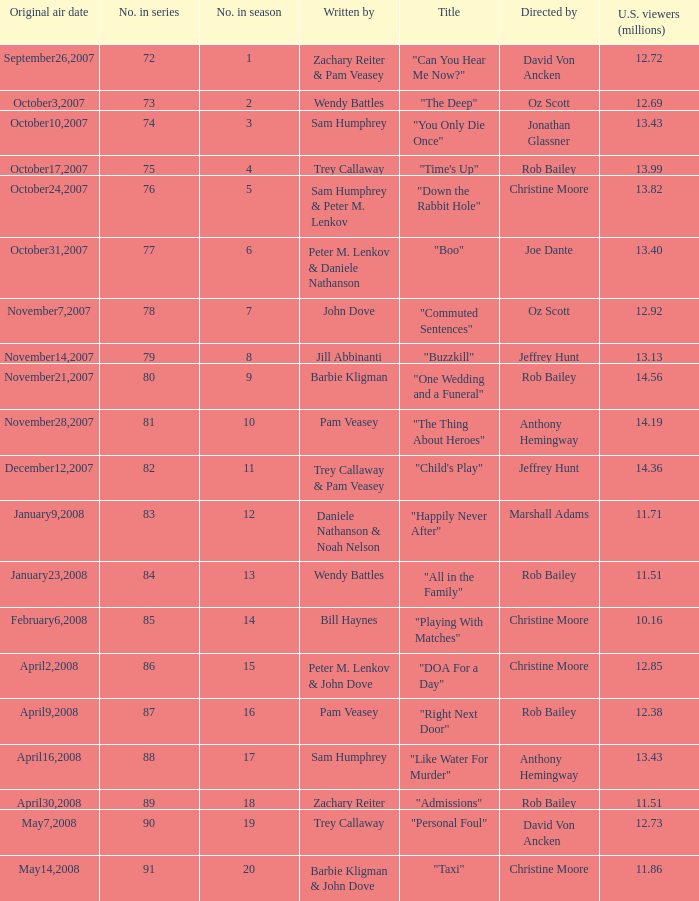How many episodes were watched by 12.72 million U.S. viewers? 1.0. 